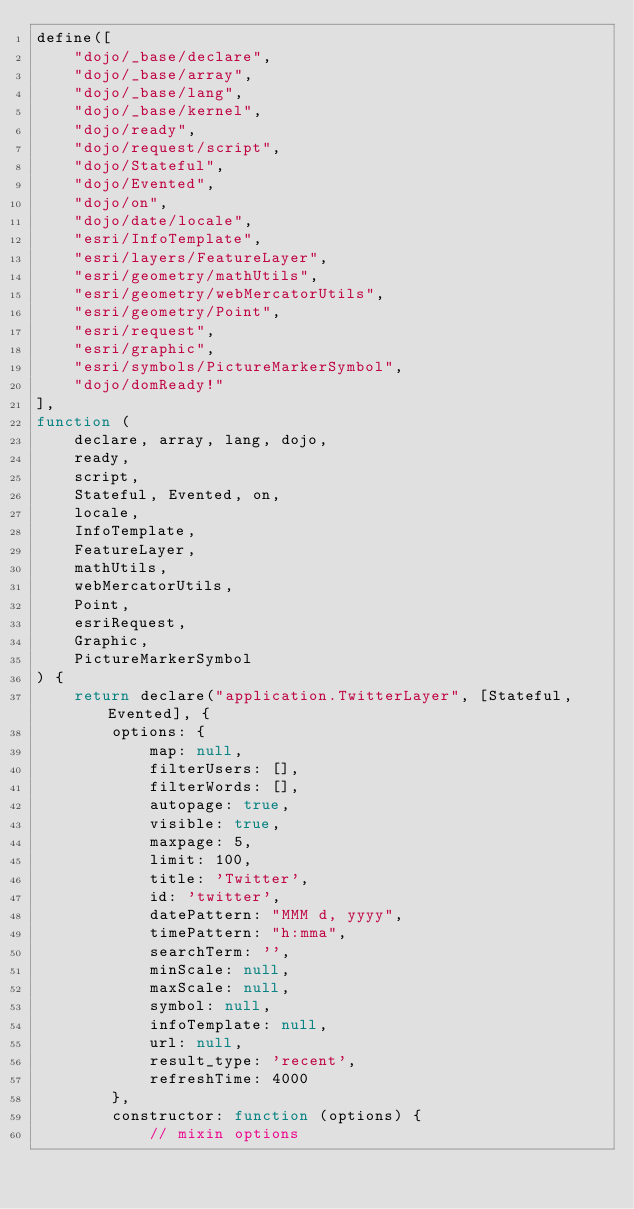Convert code to text. <code><loc_0><loc_0><loc_500><loc_500><_JavaScript_>define([
    "dojo/_base/declare",
    "dojo/_base/array",
    "dojo/_base/lang",
    "dojo/_base/kernel",
    "dojo/ready",
    "dojo/request/script",
    "dojo/Stateful",
    "dojo/Evented",
    "dojo/on",
    "dojo/date/locale",
    "esri/InfoTemplate",
    "esri/layers/FeatureLayer",
    "esri/geometry/mathUtils",
    "esri/geometry/webMercatorUtils",
    "esri/geometry/Point",
    "esri/request",
    "esri/graphic",
    "esri/symbols/PictureMarkerSymbol",
    "dojo/domReady!"
],
function (
    declare, array, lang, dojo,
    ready,
    script,
    Stateful, Evented, on,
    locale,
    InfoTemplate,
    FeatureLayer,
    mathUtils,
    webMercatorUtils,
    Point,
    esriRequest,
    Graphic,
    PictureMarkerSymbol
) {
    return declare("application.TwitterLayer", [Stateful, Evented], {
        options: {
            map: null,
            filterUsers: [],
            filterWords: [],
            autopage: true,
            visible: true,
            maxpage: 5,
            limit: 100,
            title: 'Twitter',
            id: 'twitter',
            datePattern: "MMM d, yyyy",
            timePattern: "h:mma",
            searchTerm: '',
            minScale: null,
            maxScale: null,
            symbol: null,
            infoTemplate: null,
            url: null,
            result_type: 'recent',
            refreshTime: 4000
        },
        constructor: function (options) {
            // mixin options</code> 